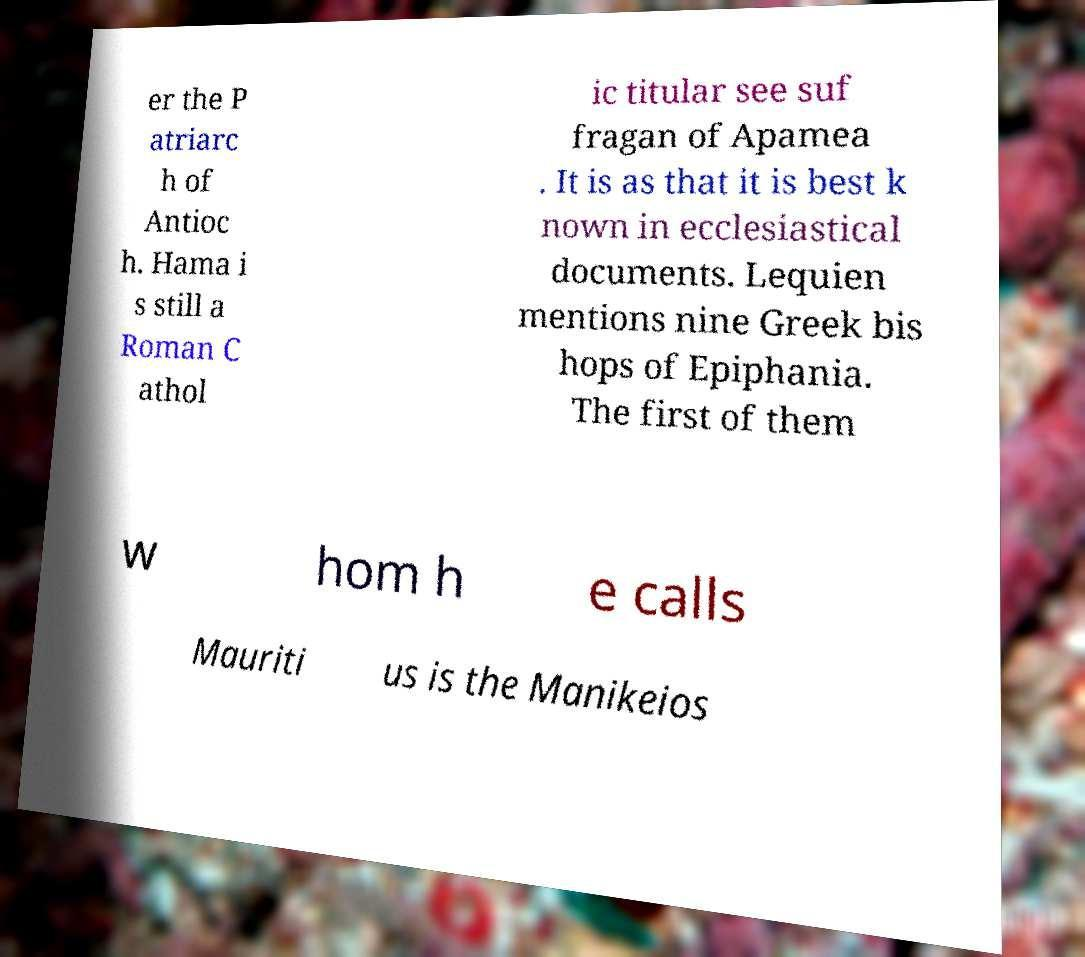For documentation purposes, I need the text within this image transcribed. Could you provide that? er the P atriarc h of Antioc h. Hama i s still a Roman C athol ic titular see suf fragan of Apamea . It is as that it is best k nown in ecclesiastical documents. Lequien mentions nine Greek bis hops of Epiphania. The first of them w hom h e calls Mauriti us is the Manikeios 